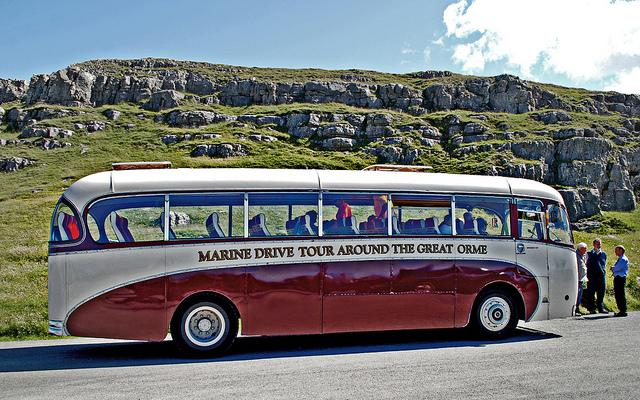What is the bus primarily used for?

Choices:
A) mail delivery
B) school transportation
C) racing
D) tours tours 